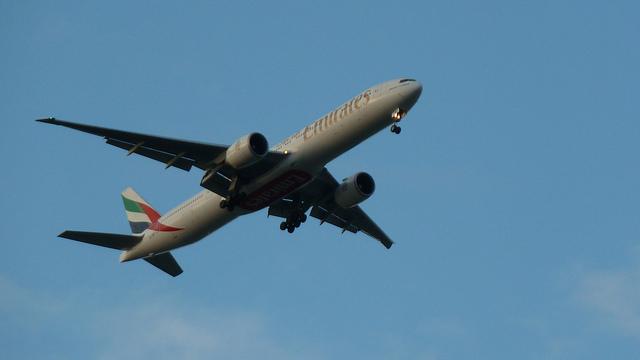What is the name of this travel company?
Give a very brief answer. Emirates. Is the plane gray?
Keep it brief. Yes. How many planes are there?
Short answer required. 1. What type of jet plane is this?
Write a very short answer. Emirates. Is the plane flying in a storm?
Keep it brief. No. 